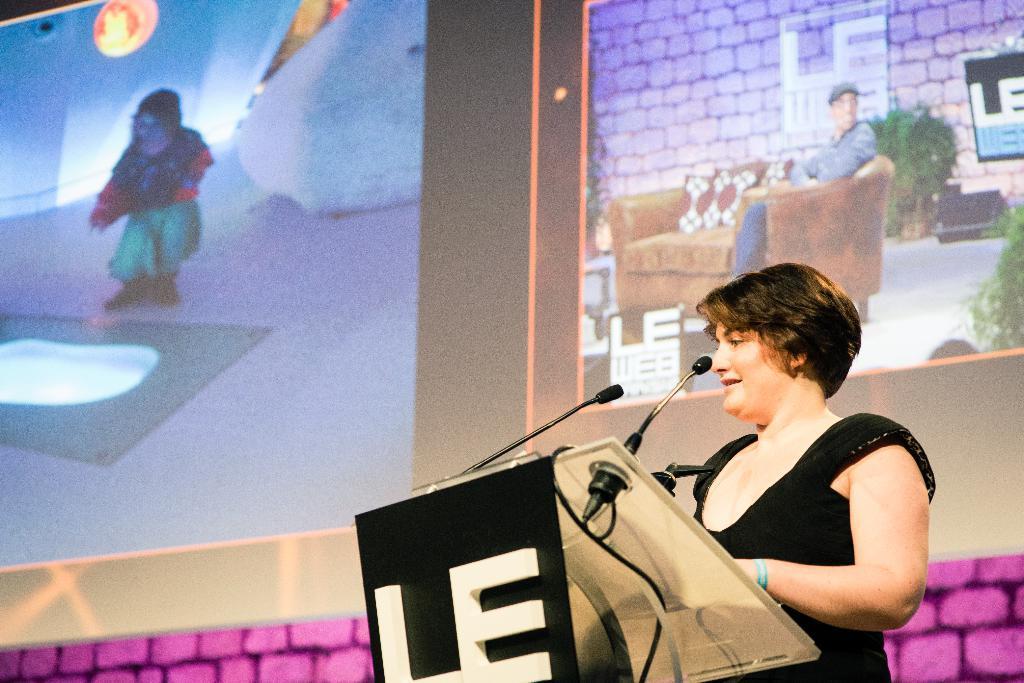Could you give a brief overview of what you see in this image? Here in this picture we can see a woman standing over a place and speaking something in the microphones present in front of her on the speech desk present in front of her and behind her we can see projector screens with somethings projected on it and we can see she is smiling. 